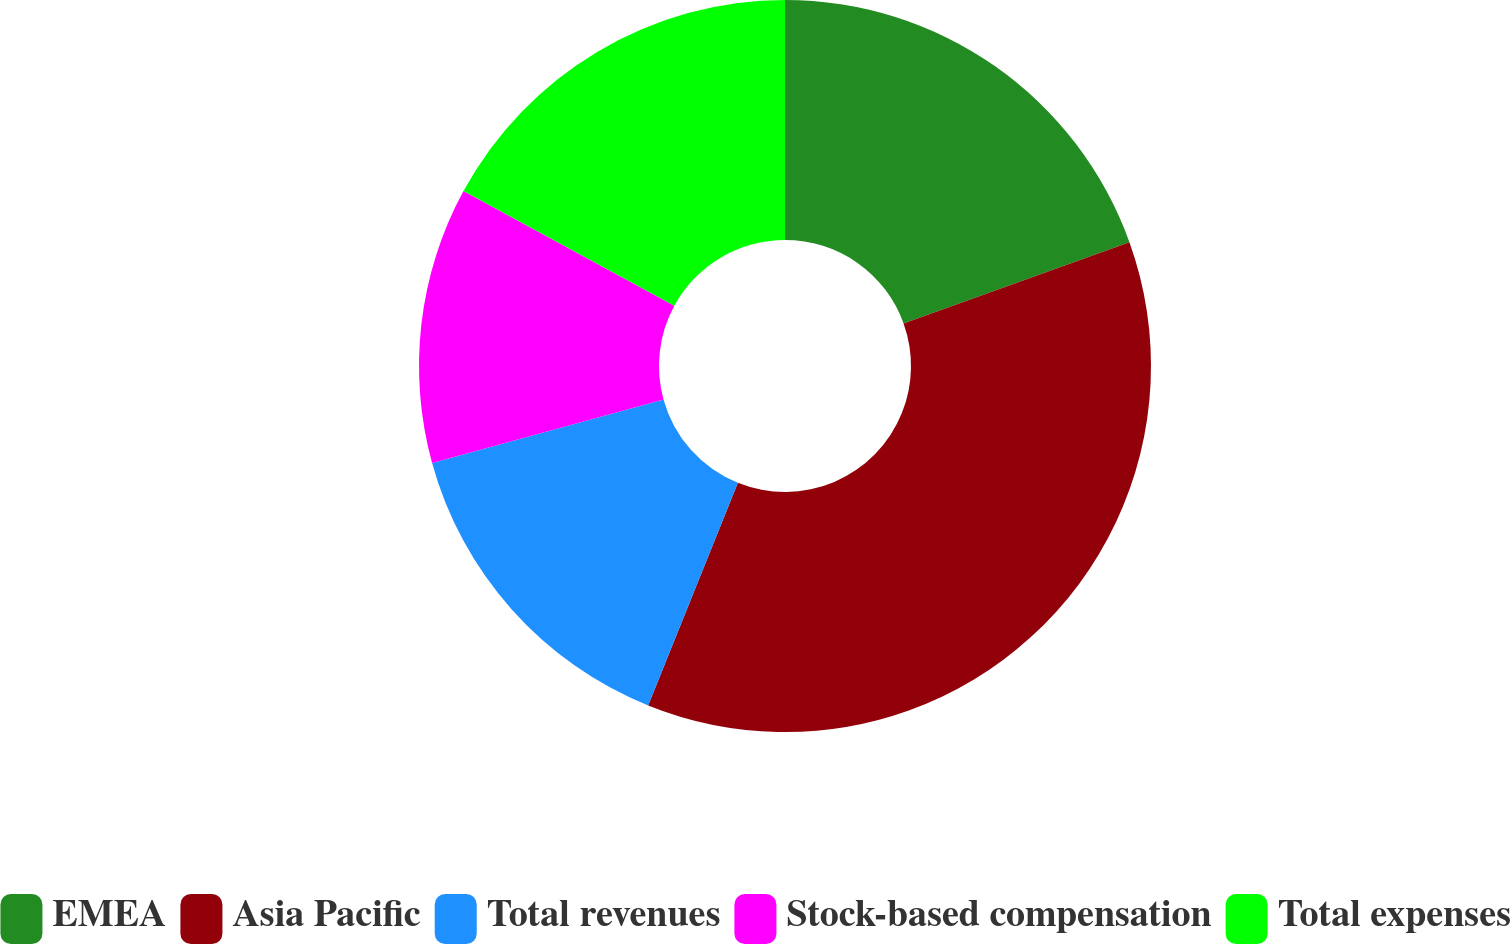Convert chart. <chart><loc_0><loc_0><loc_500><loc_500><pie_chart><fcel>EMEA<fcel>Asia Pacific<fcel>Total revenues<fcel>Stock-based compensation<fcel>Total expenses<nl><fcel>19.51%<fcel>36.59%<fcel>14.63%<fcel>12.2%<fcel>17.07%<nl></chart> 